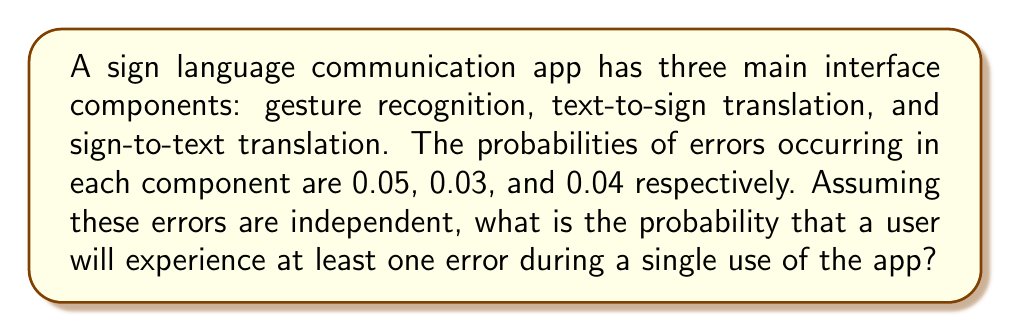Teach me how to tackle this problem. Let's approach this step-by-step:

1) First, let's define our events:
   A: Error in gesture recognition (P(A) = 0.05)
   B: Error in text-to-sign translation (P(B) = 0.03)
   C: Error in sign-to-text translation (P(C) = 0.04)

2) We want to find the probability of at least one error occurring. This is easier to calculate by finding the probability of no errors occurring and then subtracting that from 1.

3) The probability of no errors is the probability that none of A, B, or C occur:
   P(no errors) = P(not A and not B and not C)

4) Since the events are independent:
   P(no errors) = P(not A) × P(not B) × P(not C)

5) We can calculate the probability of each event not occurring:
   P(not A) = 1 - P(A) = 1 - 0.05 = 0.95
   P(not B) = 1 - P(B) = 1 - 0.03 = 0.97
   P(not C) = 1 - P(C) = 1 - 0.04 = 0.96

6) Now we can calculate:
   P(no errors) = 0.95 × 0.97 × 0.96 = 0.8836

7) Finally, the probability of at least one error is:
   P(at least one error) = 1 - P(no errors)
                         = 1 - 0.8836
                         = 0.1164

Therefore, the probability of experiencing at least one error during a single use of the app is approximately 0.1164 or 11.64%.
Answer: $0.1164$ or $11.64\%$ 